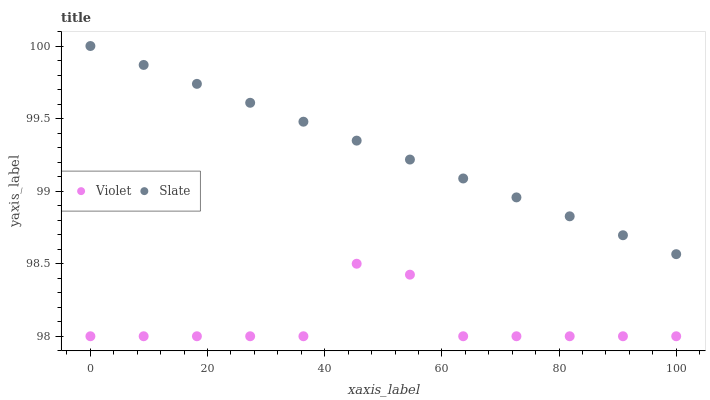Does Violet have the minimum area under the curve?
Answer yes or no. Yes. Does Slate have the maximum area under the curve?
Answer yes or no. Yes. Does Violet have the maximum area under the curve?
Answer yes or no. No. Is Slate the smoothest?
Answer yes or no. Yes. Is Violet the roughest?
Answer yes or no. Yes. Is Violet the smoothest?
Answer yes or no. No. Does Violet have the lowest value?
Answer yes or no. Yes. Does Slate have the highest value?
Answer yes or no. Yes. Does Violet have the highest value?
Answer yes or no. No. Is Violet less than Slate?
Answer yes or no. Yes. Is Slate greater than Violet?
Answer yes or no. Yes. Does Violet intersect Slate?
Answer yes or no. No. 